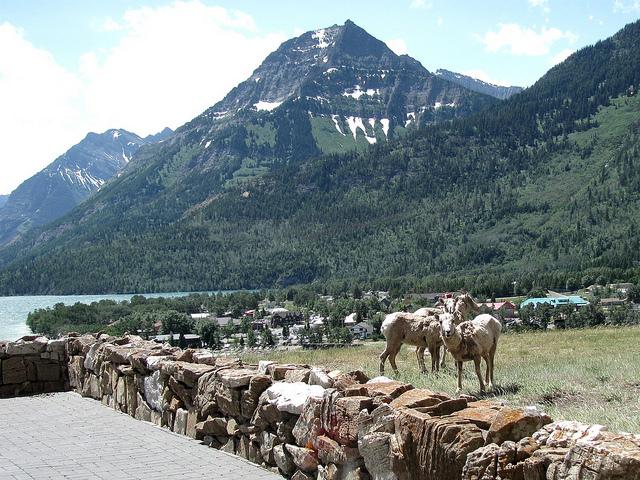What is the wall made out of?
Give a very brief answer. Stone. What is behind the animals?
Quick response, please. Mountains. Which animals are these?
Give a very brief answer. Goats. 